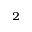<formula> <loc_0><loc_0><loc_500><loc_500>^ { 2 }</formula> 